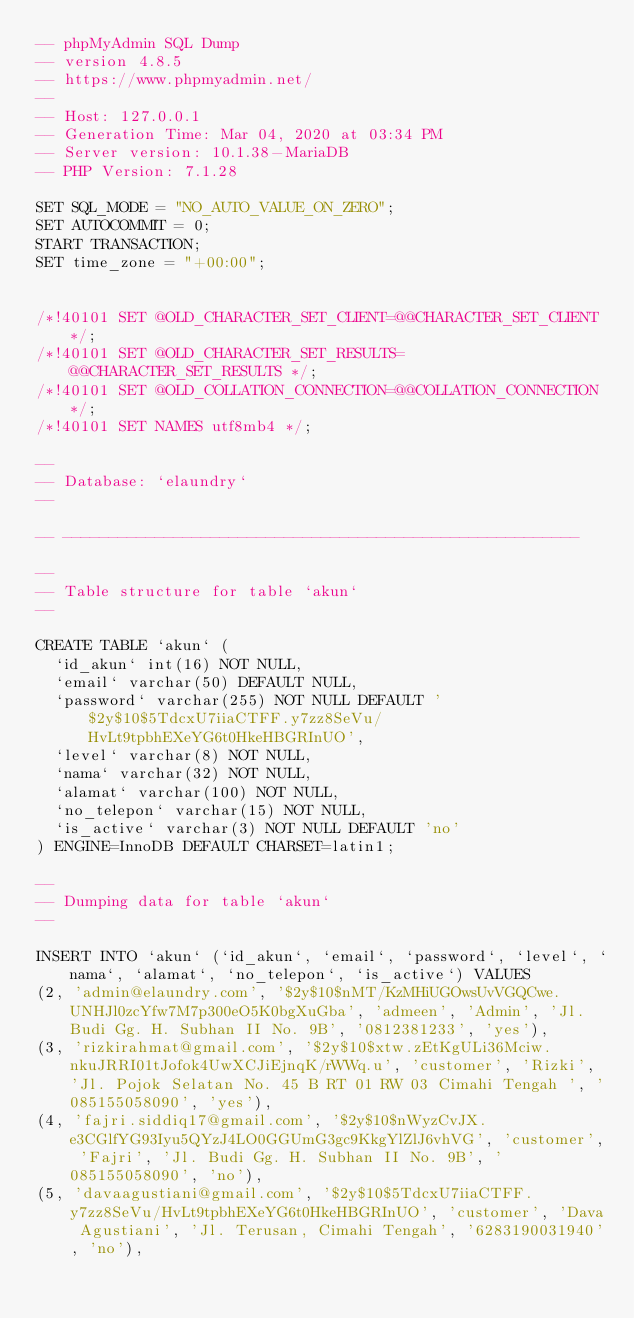<code> <loc_0><loc_0><loc_500><loc_500><_SQL_>-- phpMyAdmin SQL Dump
-- version 4.8.5
-- https://www.phpmyadmin.net/
--
-- Host: 127.0.0.1
-- Generation Time: Mar 04, 2020 at 03:34 PM
-- Server version: 10.1.38-MariaDB
-- PHP Version: 7.1.28

SET SQL_MODE = "NO_AUTO_VALUE_ON_ZERO";
SET AUTOCOMMIT = 0;
START TRANSACTION;
SET time_zone = "+00:00";


/*!40101 SET @OLD_CHARACTER_SET_CLIENT=@@CHARACTER_SET_CLIENT */;
/*!40101 SET @OLD_CHARACTER_SET_RESULTS=@@CHARACTER_SET_RESULTS */;
/*!40101 SET @OLD_COLLATION_CONNECTION=@@COLLATION_CONNECTION */;
/*!40101 SET NAMES utf8mb4 */;

--
-- Database: `elaundry`
--

-- --------------------------------------------------------

--
-- Table structure for table `akun`
--

CREATE TABLE `akun` (
  `id_akun` int(16) NOT NULL,
  `email` varchar(50) DEFAULT NULL,
  `password` varchar(255) NOT NULL DEFAULT '$2y$10$5TdcxU7iiaCTFF.y7zz8SeVu/HvLt9tpbhEXeYG6t0HkeHBGRInUO',
  `level` varchar(8) NOT NULL,
  `nama` varchar(32) NOT NULL,
  `alamat` varchar(100) NOT NULL,
  `no_telepon` varchar(15) NOT NULL,
  `is_active` varchar(3) NOT NULL DEFAULT 'no'
) ENGINE=InnoDB DEFAULT CHARSET=latin1;

--
-- Dumping data for table `akun`
--

INSERT INTO `akun` (`id_akun`, `email`, `password`, `level`, `nama`, `alamat`, `no_telepon`, `is_active`) VALUES
(2, 'admin@elaundry.com', '$2y$10$nMT/KzMHiUGOwsUvVGQCwe.UNHJl0zcYfw7M7p300eO5K0bgXuGba', 'admeen', 'Admin', 'Jl. Budi Gg. H. Subhan II No. 9B', '0812381233', 'yes'),
(3, 'rizkirahmat@gmail.com', '$2y$10$xtw.zEtKgULi36Mciw.nkuJRRI01tJofok4UwXCJiEjnqK/rWWq.u', 'customer', 'Rizki', 'Jl. Pojok Selatan No. 45 B RT 01 RW 03 Cimahi Tengah ', '085155058090', 'yes'),
(4, 'fajri.siddiq17@gmail.com', '$2y$10$nWyzCvJX.e3CGlfYG93Iyu5QYzJ4LO0GGUmG3gc9KkgYlZlJ6vhVG', 'customer', 'Fajri', 'Jl. Budi Gg. H. Subhan II No. 9B', '085155058090', 'no'),
(5, 'davaagustiani@gmail.com', '$2y$10$5TdcxU7iiaCTFF.y7zz8SeVu/HvLt9tpbhEXeYG6t0HkeHBGRInUO', 'customer', 'Dava Agustiani', 'Jl. Terusan, Cimahi Tengah', '6283190031940', 'no'),</code> 